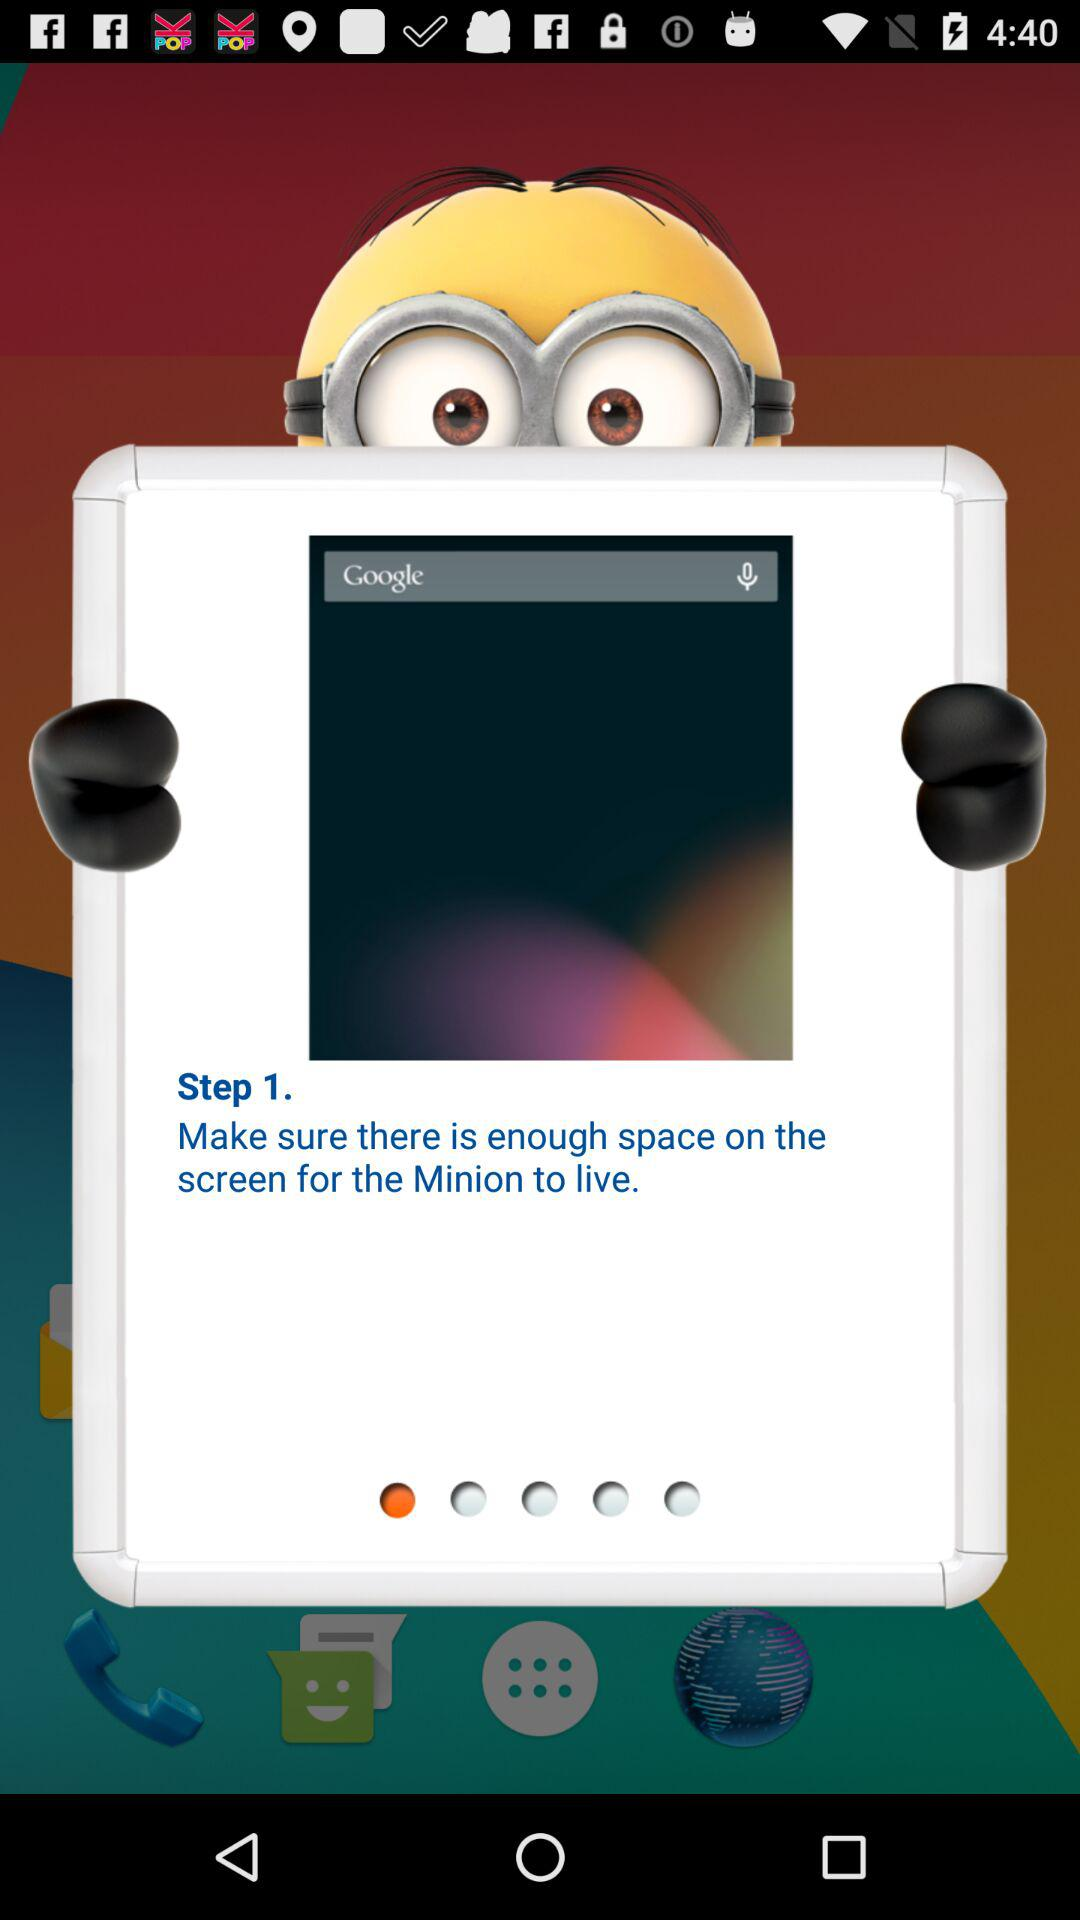How many steps are in the tutorial?
Answer the question using a single word or phrase. 1 